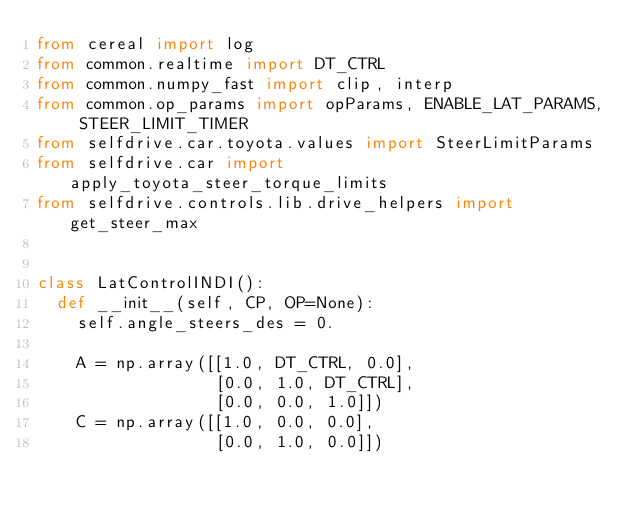<code> <loc_0><loc_0><loc_500><loc_500><_Python_>from cereal import log
from common.realtime import DT_CTRL
from common.numpy_fast import clip, interp
from common.op_params import opParams, ENABLE_LAT_PARAMS, STEER_LIMIT_TIMER
from selfdrive.car.toyota.values import SteerLimitParams
from selfdrive.car import apply_toyota_steer_torque_limits
from selfdrive.controls.lib.drive_helpers import get_steer_max


class LatControlINDI():
  def __init__(self, CP, OP=None):
    self.angle_steers_des = 0.

    A = np.array([[1.0, DT_CTRL, 0.0],
                  [0.0, 1.0, DT_CTRL],
                  [0.0, 0.0, 1.0]])
    C = np.array([[1.0, 0.0, 0.0],
                  [0.0, 1.0, 0.0]])
</code> 